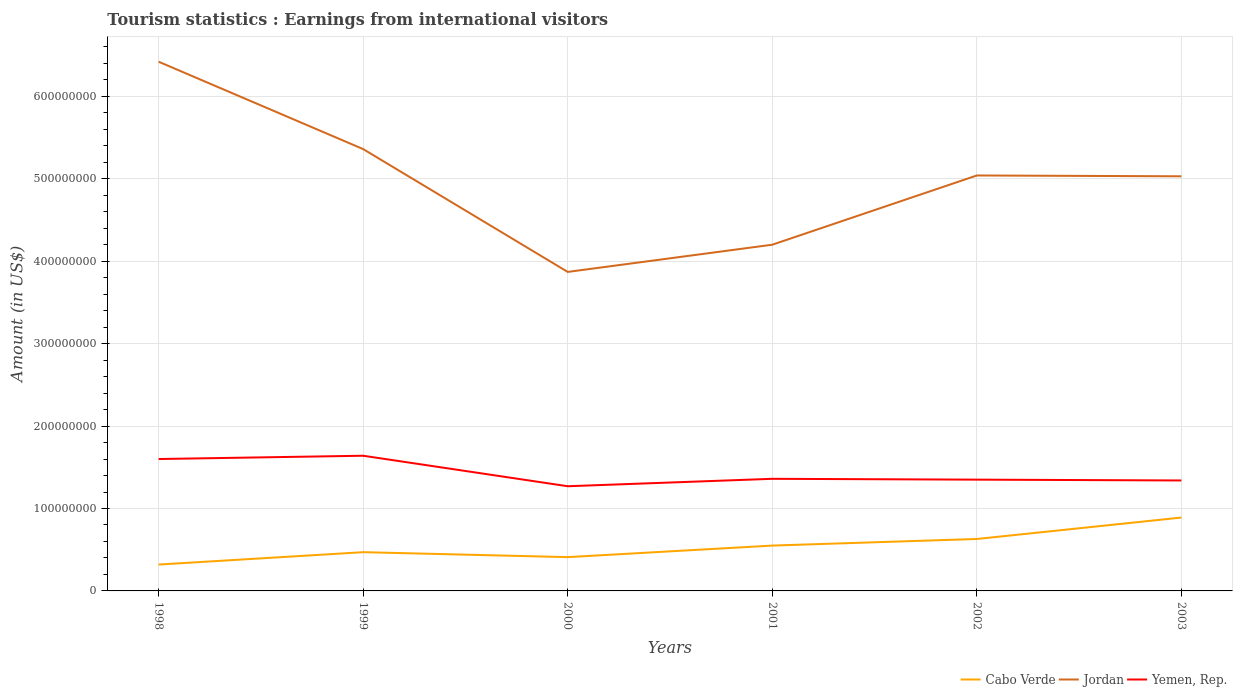How many different coloured lines are there?
Your response must be concise. 3. Is the number of lines equal to the number of legend labels?
Provide a succinct answer. Yes. Across all years, what is the maximum earnings from international visitors in Cabo Verde?
Offer a terse response. 3.20e+07. In which year was the earnings from international visitors in Yemen, Rep. maximum?
Your answer should be compact. 2000. What is the total earnings from international visitors in Jordan in the graph?
Your answer should be very brief. 3.30e+07. What is the difference between the highest and the second highest earnings from international visitors in Jordan?
Ensure brevity in your answer.  2.55e+08. How many years are there in the graph?
Your answer should be very brief. 6. Does the graph contain grids?
Your answer should be compact. Yes. How many legend labels are there?
Provide a succinct answer. 3. How are the legend labels stacked?
Your answer should be compact. Horizontal. What is the title of the graph?
Provide a succinct answer. Tourism statistics : Earnings from international visitors. Does "Ghana" appear as one of the legend labels in the graph?
Your answer should be very brief. No. What is the label or title of the X-axis?
Provide a succinct answer. Years. What is the Amount (in US$) of Cabo Verde in 1998?
Your answer should be compact. 3.20e+07. What is the Amount (in US$) of Jordan in 1998?
Provide a short and direct response. 6.42e+08. What is the Amount (in US$) of Yemen, Rep. in 1998?
Give a very brief answer. 1.60e+08. What is the Amount (in US$) in Cabo Verde in 1999?
Make the answer very short. 4.70e+07. What is the Amount (in US$) in Jordan in 1999?
Make the answer very short. 5.36e+08. What is the Amount (in US$) of Yemen, Rep. in 1999?
Make the answer very short. 1.64e+08. What is the Amount (in US$) in Cabo Verde in 2000?
Provide a succinct answer. 4.10e+07. What is the Amount (in US$) of Jordan in 2000?
Your answer should be compact. 3.87e+08. What is the Amount (in US$) in Yemen, Rep. in 2000?
Your answer should be compact. 1.27e+08. What is the Amount (in US$) of Cabo Verde in 2001?
Provide a succinct answer. 5.50e+07. What is the Amount (in US$) of Jordan in 2001?
Your answer should be very brief. 4.20e+08. What is the Amount (in US$) in Yemen, Rep. in 2001?
Your answer should be very brief. 1.36e+08. What is the Amount (in US$) of Cabo Verde in 2002?
Your answer should be compact. 6.30e+07. What is the Amount (in US$) of Jordan in 2002?
Offer a terse response. 5.04e+08. What is the Amount (in US$) of Yemen, Rep. in 2002?
Offer a very short reply. 1.35e+08. What is the Amount (in US$) of Cabo Verde in 2003?
Your answer should be very brief. 8.90e+07. What is the Amount (in US$) in Jordan in 2003?
Provide a succinct answer. 5.03e+08. What is the Amount (in US$) of Yemen, Rep. in 2003?
Make the answer very short. 1.34e+08. Across all years, what is the maximum Amount (in US$) of Cabo Verde?
Provide a succinct answer. 8.90e+07. Across all years, what is the maximum Amount (in US$) of Jordan?
Provide a short and direct response. 6.42e+08. Across all years, what is the maximum Amount (in US$) in Yemen, Rep.?
Offer a terse response. 1.64e+08. Across all years, what is the minimum Amount (in US$) of Cabo Verde?
Make the answer very short. 3.20e+07. Across all years, what is the minimum Amount (in US$) of Jordan?
Ensure brevity in your answer.  3.87e+08. Across all years, what is the minimum Amount (in US$) of Yemen, Rep.?
Provide a short and direct response. 1.27e+08. What is the total Amount (in US$) of Cabo Verde in the graph?
Give a very brief answer. 3.27e+08. What is the total Amount (in US$) of Jordan in the graph?
Make the answer very short. 2.99e+09. What is the total Amount (in US$) in Yemen, Rep. in the graph?
Your answer should be compact. 8.56e+08. What is the difference between the Amount (in US$) in Cabo Verde in 1998 and that in 1999?
Offer a terse response. -1.50e+07. What is the difference between the Amount (in US$) in Jordan in 1998 and that in 1999?
Provide a short and direct response. 1.06e+08. What is the difference between the Amount (in US$) of Cabo Verde in 1998 and that in 2000?
Give a very brief answer. -9.00e+06. What is the difference between the Amount (in US$) in Jordan in 1998 and that in 2000?
Your answer should be compact. 2.55e+08. What is the difference between the Amount (in US$) in Yemen, Rep. in 1998 and that in 2000?
Ensure brevity in your answer.  3.30e+07. What is the difference between the Amount (in US$) of Cabo Verde in 1998 and that in 2001?
Provide a succinct answer. -2.30e+07. What is the difference between the Amount (in US$) in Jordan in 1998 and that in 2001?
Your response must be concise. 2.22e+08. What is the difference between the Amount (in US$) of Yemen, Rep. in 1998 and that in 2001?
Make the answer very short. 2.40e+07. What is the difference between the Amount (in US$) of Cabo Verde in 1998 and that in 2002?
Ensure brevity in your answer.  -3.10e+07. What is the difference between the Amount (in US$) of Jordan in 1998 and that in 2002?
Keep it short and to the point. 1.38e+08. What is the difference between the Amount (in US$) in Yemen, Rep. in 1998 and that in 2002?
Your answer should be compact. 2.50e+07. What is the difference between the Amount (in US$) of Cabo Verde in 1998 and that in 2003?
Keep it short and to the point. -5.70e+07. What is the difference between the Amount (in US$) in Jordan in 1998 and that in 2003?
Provide a short and direct response. 1.39e+08. What is the difference between the Amount (in US$) of Yemen, Rep. in 1998 and that in 2003?
Provide a short and direct response. 2.60e+07. What is the difference between the Amount (in US$) in Jordan in 1999 and that in 2000?
Your answer should be compact. 1.49e+08. What is the difference between the Amount (in US$) in Yemen, Rep. in 1999 and that in 2000?
Your response must be concise. 3.70e+07. What is the difference between the Amount (in US$) of Cabo Verde in 1999 and that in 2001?
Your response must be concise. -8.00e+06. What is the difference between the Amount (in US$) in Jordan in 1999 and that in 2001?
Offer a terse response. 1.16e+08. What is the difference between the Amount (in US$) in Yemen, Rep. in 1999 and that in 2001?
Your answer should be compact. 2.80e+07. What is the difference between the Amount (in US$) of Cabo Verde in 1999 and that in 2002?
Keep it short and to the point. -1.60e+07. What is the difference between the Amount (in US$) in Jordan in 1999 and that in 2002?
Give a very brief answer. 3.20e+07. What is the difference between the Amount (in US$) in Yemen, Rep. in 1999 and that in 2002?
Your answer should be very brief. 2.90e+07. What is the difference between the Amount (in US$) of Cabo Verde in 1999 and that in 2003?
Make the answer very short. -4.20e+07. What is the difference between the Amount (in US$) of Jordan in 1999 and that in 2003?
Make the answer very short. 3.30e+07. What is the difference between the Amount (in US$) of Yemen, Rep. in 1999 and that in 2003?
Offer a terse response. 3.00e+07. What is the difference between the Amount (in US$) in Cabo Verde in 2000 and that in 2001?
Make the answer very short. -1.40e+07. What is the difference between the Amount (in US$) in Jordan in 2000 and that in 2001?
Your answer should be compact. -3.30e+07. What is the difference between the Amount (in US$) of Yemen, Rep. in 2000 and that in 2001?
Provide a short and direct response. -9.00e+06. What is the difference between the Amount (in US$) of Cabo Verde in 2000 and that in 2002?
Offer a very short reply. -2.20e+07. What is the difference between the Amount (in US$) in Jordan in 2000 and that in 2002?
Give a very brief answer. -1.17e+08. What is the difference between the Amount (in US$) in Yemen, Rep. in 2000 and that in 2002?
Provide a short and direct response. -8.00e+06. What is the difference between the Amount (in US$) of Cabo Verde in 2000 and that in 2003?
Give a very brief answer. -4.80e+07. What is the difference between the Amount (in US$) in Jordan in 2000 and that in 2003?
Keep it short and to the point. -1.16e+08. What is the difference between the Amount (in US$) in Yemen, Rep. in 2000 and that in 2003?
Make the answer very short. -7.00e+06. What is the difference between the Amount (in US$) in Cabo Verde in 2001 and that in 2002?
Keep it short and to the point. -8.00e+06. What is the difference between the Amount (in US$) in Jordan in 2001 and that in 2002?
Your answer should be compact. -8.40e+07. What is the difference between the Amount (in US$) in Cabo Verde in 2001 and that in 2003?
Offer a terse response. -3.40e+07. What is the difference between the Amount (in US$) in Jordan in 2001 and that in 2003?
Make the answer very short. -8.30e+07. What is the difference between the Amount (in US$) of Yemen, Rep. in 2001 and that in 2003?
Your response must be concise. 2.00e+06. What is the difference between the Amount (in US$) of Cabo Verde in 2002 and that in 2003?
Provide a succinct answer. -2.60e+07. What is the difference between the Amount (in US$) of Cabo Verde in 1998 and the Amount (in US$) of Jordan in 1999?
Offer a terse response. -5.04e+08. What is the difference between the Amount (in US$) of Cabo Verde in 1998 and the Amount (in US$) of Yemen, Rep. in 1999?
Offer a very short reply. -1.32e+08. What is the difference between the Amount (in US$) in Jordan in 1998 and the Amount (in US$) in Yemen, Rep. in 1999?
Your answer should be very brief. 4.78e+08. What is the difference between the Amount (in US$) of Cabo Verde in 1998 and the Amount (in US$) of Jordan in 2000?
Ensure brevity in your answer.  -3.55e+08. What is the difference between the Amount (in US$) in Cabo Verde in 1998 and the Amount (in US$) in Yemen, Rep. in 2000?
Keep it short and to the point. -9.50e+07. What is the difference between the Amount (in US$) of Jordan in 1998 and the Amount (in US$) of Yemen, Rep. in 2000?
Give a very brief answer. 5.15e+08. What is the difference between the Amount (in US$) of Cabo Verde in 1998 and the Amount (in US$) of Jordan in 2001?
Offer a very short reply. -3.88e+08. What is the difference between the Amount (in US$) of Cabo Verde in 1998 and the Amount (in US$) of Yemen, Rep. in 2001?
Keep it short and to the point. -1.04e+08. What is the difference between the Amount (in US$) of Jordan in 1998 and the Amount (in US$) of Yemen, Rep. in 2001?
Your response must be concise. 5.06e+08. What is the difference between the Amount (in US$) in Cabo Verde in 1998 and the Amount (in US$) in Jordan in 2002?
Make the answer very short. -4.72e+08. What is the difference between the Amount (in US$) in Cabo Verde in 1998 and the Amount (in US$) in Yemen, Rep. in 2002?
Provide a succinct answer. -1.03e+08. What is the difference between the Amount (in US$) in Jordan in 1998 and the Amount (in US$) in Yemen, Rep. in 2002?
Offer a very short reply. 5.07e+08. What is the difference between the Amount (in US$) in Cabo Verde in 1998 and the Amount (in US$) in Jordan in 2003?
Ensure brevity in your answer.  -4.71e+08. What is the difference between the Amount (in US$) of Cabo Verde in 1998 and the Amount (in US$) of Yemen, Rep. in 2003?
Provide a short and direct response. -1.02e+08. What is the difference between the Amount (in US$) in Jordan in 1998 and the Amount (in US$) in Yemen, Rep. in 2003?
Provide a succinct answer. 5.08e+08. What is the difference between the Amount (in US$) of Cabo Verde in 1999 and the Amount (in US$) of Jordan in 2000?
Your response must be concise. -3.40e+08. What is the difference between the Amount (in US$) in Cabo Verde in 1999 and the Amount (in US$) in Yemen, Rep. in 2000?
Offer a very short reply. -8.00e+07. What is the difference between the Amount (in US$) in Jordan in 1999 and the Amount (in US$) in Yemen, Rep. in 2000?
Provide a short and direct response. 4.09e+08. What is the difference between the Amount (in US$) in Cabo Verde in 1999 and the Amount (in US$) in Jordan in 2001?
Provide a succinct answer. -3.73e+08. What is the difference between the Amount (in US$) of Cabo Verde in 1999 and the Amount (in US$) of Yemen, Rep. in 2001?
Give a very brief answer. -8.90e+07. What is the difference between the Amount (in US$) of Jordan in 1999 and the Amount (in US$) of Yemen, Rep. in 2001?
Offer a very short reply. 4.00e+08. What is the difference between the Amount (in US$) of Cabo Verde in 1999 and the Amount (in US$) of Jordan in 2002?
Ensure brevity in your answer.  -4.57e+08. What is the difference between the Amount (in US$) of Cabo Verde in 1999 and the Amount (in US$) of Yemen, Rep. in 2002?
Make the answer very short. -8.80e+07. What is the difference between the Amount (in US$) in Jordan in 1999 and the Amount (in US$) in Yemen, Rep. in 2002?
Your answer should be very brief. 4.01e+08. What is the difference between the Amount (in US$) of Cabo Verde in 1999 and the Amount (in US$) of Jordan in 2003?
Ensure brevity in your answer.  -4.56e+08. What is the difference between the Amount (in US$) of Cabo Verde in 1999 and the Amount (in US$) of Yemen, Rep. in 2003?
Your response must be concise. -8.70e+07. What is the difference between the Amount (in US$) in Jordan in 1999 and the Amount (in US$) in Yemen, Rep. in 2003?
Your response must be concise. 4.02e+08. What is the difference between the Amount (in US$) of Cabo Verde in 2000 and the Amount (in US$) of Jordan in 2001?
Provide a succinct answer. -3.79e+08. What is the difference between the Amount (in US$) in Cabo Verde in 2000 and the Amount (in US$) in Yemen, Rep. in 2001?
Your answer should be very brief. -9.50e+07. What is the difference between the Amount (in US$) of Jordan in 2000 and the Amount (in US$) of Yemen, Rep. in 2001?
Provide a short and direct response. 2.51e+08. What is the difference between the Amount (in US$) in Cabo Verde in 2000 and the Amount (in US$) in Jordan in 2002?
Provide a succinct answer. -4.63e+08. What is the difference between the Amount (in US$) of Cabo Verde in 2000 and the Amount (in US$) of Yemen, Rep. in 2002?
Make the answer very short. -9.40e+07. What is the difference between the Amount (in US$) of Jordan in 2000 and the Amount (in US$) of Yemen, Rep. in 2002?
Offer a very short reply. 2.52e+08. What is the difference between the Amount (in US$) of Cabo Verde in 2000 and the Amount (in US$) of Jordan in 2003?
Keep it short and to the point. -4.62e+08. What is the difference between the Amount (in US$) of Cabo Verde in 2000 and the Amount (in US$) of Yemen, Rep. in 2003?
Ensure brevity in your answer.  -9.30e+07. What is the difference between the Amount (in US$) in Jordan in 2000 and the Amount (in US$) in Yemen, Rep. in 2003?
Offer a very short reply. 2.53e+08. What is the difference between the Amount (in US$) of Cabo Verde in 2001 and the Amount (in US$) of Jordan in 2002?
Your response must be concise. -4.49e+08. What is the difference between the Amount (in US$) in Cabo Verde in 2001 and the Amount (in US$) in Yemen, Rep. in 2002?
Provide a succinct answer. -8.00e+07. What is the difference between the Amount (in US$) of Jordan in 2001 and the Amount (in US$) of Yemen, Rep. in 2002?
Your response must be concise. 2.85e+08. What is the difference between the Amount (in US$) in Cabo Verde in 2001 and the Amount (in US$) in Jordan in 2003?
Give a very brief answer. -4.48e+08. What is the difference between the Amount (in US$) of Cabo Verde in 2001 and the Amount (in US$) of Yemen, Rep. in 2003?
Your answer should be compact. -7.90e+07. What is the difference between the Amount (in US$) of Jordan in 2001 and the Amount (in US$) of Yemen, Rep. in 2003?
Offer a very short reply. 2.86e+08. What is the difference between the Amount (in US$) of Cabo Verde in 2002 and the Amount (in US$) of Jordan in 2003?
Offer a very short reply. -4.40e+08. What is the difference between the Amount (in US$) in Cabo Verde in 2002 and the Amount (in US$) in Yemen, Rep. in 2003?
Provide a short and direct response. -7.10e+07. What is the difference between the Amount (in US$) of Jordan in 2002 and the Amount (in US$) of Yemen, Rep. in 2003?
Give a very brief answer. 3.70e+08. What is the average Amount (in US$) in Cabo Verde per year?
Offer a terse response. 5.45e+07. What is the average Amount (in US$) of Jordan per year?
Make the answer very short. 4.99e+08. What is the average Amount (in US$) in Yemen, Rep. per year?
Make the answer very short. 1.43e+08. In the year 1998, what is the difference between the Amount (in US$) in Cabo Verde and Amount (in US$) in Jordan?
Give a very brief answer. -6.10e+08. In the year 1998, what is the difference between the Amount (in US$) of Cabo Verde and Amount (in US$) of Yemen, Rep.?
Offer a terse response. -1.28e+08. In the year 1998, what is the difference between the Amount (in US$) of Jordan and Amount (in US$) of Yemen, Rep.?
Ensure brevity in your answer.  4.82e+08. In the year 1999, what is the difference between the Amount (in US$) in Cabo Verde and Amount (in US$) in Jordan?
Your answer should be very brief. -4.89e+08. In the year 1999, what is the difference between the Amount (in US$) in Cabo Verde and Amount (in US$) in Yemen, Rep.?
Provide a succinct answer. -1.17e+08. In the year 1999, what is the difference between the Amount (in US$) in Jordan and Amount (in US$) in Yemen, Rep.?
Ensure brevity in your answer.  3.72e+08. In the year 2000, what is the difference between the Amount (in US$) in Cabo Verde and Amount (in US$) in Jordan?
Your answer should be very brief. -3.46e+08. In the year 2000, what is the difference between the Amount (in US$) of Cabo Verde and Amount (in US$) of Yemen, Rep.?
Your response must be concise. -8.60e+07. In the year 2000, what is the difference between the Amount (in US$) of Jordan and Amount (in US$) of Yemen, Rep.?
Make the answer very short. 2.60e+08. In the year 2001, what is the difference between the Amount (in US$) of Cabo Verde and Amount (in US$) of Jordan?
Give a very brief answer. -3.65e+08. In the year 2001, what is the difference between the Amount (in US$) in Cabo Verde and Amount (in US$) in Yemen, Rep.?
Your answer should be compact. -8.10e+07. In the year 2001, what is the difference between the Amount (in US$) of Jordan and Amount (in US$) of Yemen, Rep.?
Offer a terse response. 2.84e+08. In the year 2002, what is the difference between the Amount (in US$) of Cabo Verde and Amount (in US$) of Jordan?
Give a very brief answer. -4.41e+08. In the year 2002, what is the difference between the Amount (in US$) of Cabo Verde and Amount (in US$) of Yemen, Rep.?
Provide a short and direct response. -7.20e+07. In the year 2002, what is the difference between the Amount (in US$) of Jordan and Amount (in US$) of Yemen, Rep.?
Offer a terse response. 3.69e+08. In the year 2003, what is the difference between the Amount (in US$) of Cabo Verde and Amount (in US$) of Jordan?
Make the answer very short. -4.14e+08. In the year 2003, what is the difference between the Amount (in US$) of Cabo Verde and Amount (in US$) of Yemen, Rep.?
Provide a short and direct response. -4.50e+07. In the year 2003, what is the difference between the Amount (in US$) of Jordan and Amount (in US$) of Yemen, Rep.?
Provide a succinct answer. 3.69e+08. What is the ratio of the Amount (in US$) in Cabo Verde in 1998 to that in 1999?
Your answer should be very brief. 0.68. What is the ratio of the Amount (in US$) of Jordan in 1998 to that in 1999?
Provide a short and direct response. 1.2. What is the ratio of the Amount (in US$) in Yemen, Rep. in 1998 to that in 1999?
Give a very brief answer. 0.98. What is the ratio of the Amount (in US$) in Cabo Verde in 1998 to that in 2000?
Your answer should be compact. 0.78. What is the ratio of the Amount (in US$) in Jordan in 1998 to that in 2000?
Your response must be concise. 1.66. What is the ratio of the Amount (in US$) of Yemen, Rep. in 1998 to that in 2000?
Give a very brief answer. 1.26. What is the ratio of the Amount (in US$) of Cabo Verde in 1998 to that in 2001?
Ensure brevity in your answer.  0.58. What is the ratio of the Amount (in US$) of Jordan in 1998 to that in 2001?
Keep it short and to the point. 1.53. What is the ratio of the Amount (in US$) in Yemen, Rep. in 1998 to that in 2001?
Offer a terse response. 1.18. What is the ratio of the Amount (in US$) of Cabo Verde in 1998 to that in 2002?
Your answer should be very brief. 0.51. What is the ratio of the Amount (in US$) of Jordan in 1998 to that in 2002?
Your answer should be compact. 1.27. What is the ratio of the Amount (in US$) of Yemen, Rep. in 1998 to that in 2002?
Ensure brevity in your answer.  1.19. What is the ratio of the Amount (in US$) of Cabo Verde in 1998 to that in 2003?
Your response must be concise. 0.36. What is the ratio of the Amount (in US$) of Jordan in 1998 to that in 2003?
Provide a short and direct response. 1.28. What is the ratio of the Amount (in US$) of Yemen, Rep. in 1998 to that in 2003?
Ensure brevity in your answer.  1.19. What is the ratio of the Amount (in US$) in Cabo Verde in 1999 to that in 2000?
Ensure brevity in your answer.  1.15. What is the ratio of the Amount (in US$) in Jordan in 1999 to that in 2000?
Keep it short and to the point. 1.39. What is the ratio of the Amount (in US$) of Yemen, Rep. in 1999 to that in 2000?
Provide a succinct answer. 1.29. What is the ratio of the Amount (in US$) in Cabo Verde in 1999 to that in 2001?
Give a very brief answer. 0.85. What is the ratio of the Amount (in US$) in Jordan in 1999 to that in 2001?
Ensure brevity in your answer.  1.28. What is the ratio of the Amount (in US$) in Yemen, Rep. in 1999 to that in 2001?
Your answer should be compact. 1.21. What is the ratio of the Amount (in US$) of Cabo Verde in 1999 to that in 2002?
Your answer should be very brief. 0.75. What is the ratio of the Amount (in US$) in Jordan in 1999 to that in 2002?
Your response must be concise. 1.06. What is the ratio of the Amount (in US$) in Yemen, Rep. in 1999 to that in 2002?
Ensure brevity in your answer.  1.21. What is the ratio of the Amount (in US$) of Cabo Verde in 1999 to that in 2003?
Your answer should be very brief. 0.53. What is the ratio of the Amount (in US$) in Jordan in 1999 to that in 2003?
Your answer should be very brief. 1.07. What is the ratio of the Amount (in US$) of Yemen, Rep. in 1999 to that in 2003?
Provide a short and direct response. 1.22. What is the ratio of the Amount (in US$) in Cabo Verde in 2000 to that in 2001?
Your answer should be very brief. 0.75. What is the ratio of the Amount (in US$) in Jordan in 2000 to that in 2001?
Your answer should be compact. 0.92. What is the ratio of the Amount (in US$) in Yemen, Rep. in 2000 to that in 2001?
Your response must be concise. 0.93. What is the ratio of the Amount (in US$) in Cabo Verde in 2000 to that in 2002?
Your answer should be compact. 0.65. What is the ratio of the Amount (in US$) of Jordan in 2000 to that in 2002?
Offer a very short reply. 0.77. What is the ratio of the Amount (in US$) in Yemen, Rep. in 2000 to that in 2002?
Your answer should be very brief. 0.94. What is the ratio of the Amount (in US$) of Cabo Verde in 2000 to that in 2003?
Provide a short and direct response. 0.46. What is the ratio of the Amount (in US$) in Jordan in 2000 to that in 2003?
Your answer should be compact. 0.77. What is the ratio of the Amount (in US$) of Yemen, Rep. in 2000 to that in 2003?
Provide a short and direct response. 0.95. What is the ratio of the Amount (in US$) of Cabo Verde in 2001 to that in 2002?
Provide a succinct answer. 0.87. What is the ratio of the Amount (in US$) in Yemen, Rep. in 2001 to that in 2002?
Give a very brief answer. 1.01. What is the ratio of the Amount (in US$) of Cabo Verde in 2001 to that in 2003?
Provide a succinct answer. 0.62. What is the ratio of the Amount (in US$) of Jordan in 2001 to that in 2003?
Give a very brief answer. 0.83. What is the ratio of the Amount (in US$) in Yemen, Rep. in 2001 to that in 2003?
Make the answer very short. 1.01. What is the ratio of the Amount (in US$) of Cabo Verde in 2002 to that in 2003?
Offer a terse response. 0.71. What is the ratio of the Amount (in US$) of Yemen, Rep. in 2002 to that in 2003?
Make the answer very short. 1.01. What is the difference between the highest and the second highest Amount (in US$) of Cabo Verde?
Your response must be concise. 2.60e+07. What is the difference between the highest and the second highest Amount (in US$) in Jordan?
Your response must be concise. 1.06e+08. What is the difference between the highest and the lowest Amount (in US$) in Cabo Verde?
Provide a short and direct response. 5.70e+07. What is the difference between the highest and the lowest Amount (in US$) in Jordan?
Provide a short and direct response. 2.55e+08. What is the difference between the highest and the lowest Amount (in US$) of Yemen, Rep.?
Your answer should be very brief. 3.70e+07. 